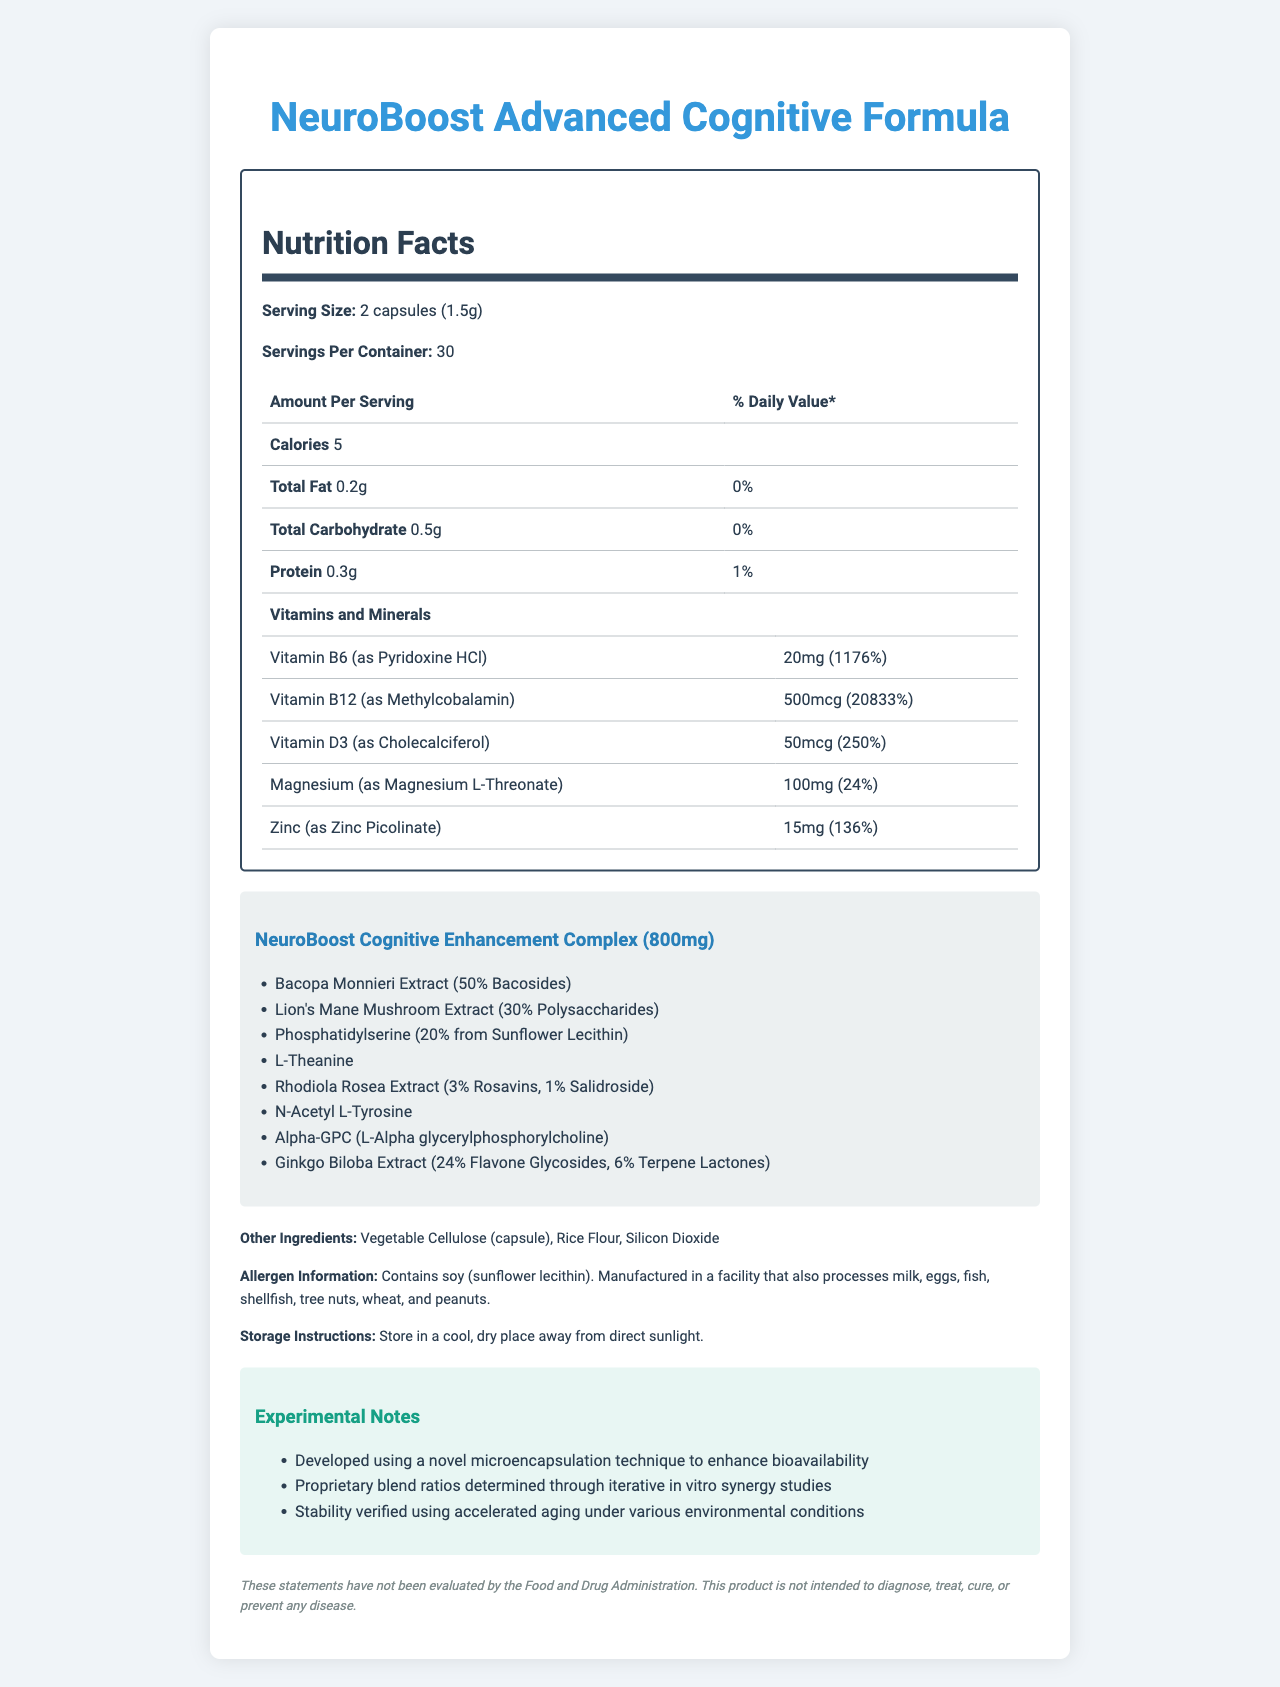what is the serving size for NeuroBoost Advanced Cognitive Formula? The serving size is listed as "2 capsules (1.5g)" in the document.
Answer: 2 capsules (1.5g) how many servings per container are there? The document states that there are 30 servings per container.
Answer: 30 how many calories are there per serving? The number of calories per serving is listed as 5.
Answer: 5 what is the proprietary blend amount per serving? The proprietary blend amount per serving is specifically mentioned as 800mg.
Answer: 800mg which vitamin has the highest daily value percentage? Vitamin B12 (as Methylcobalamin) has a daily value percentage of 20833%, which is the highest among the listed vitamins and minerals.
Answer: Vitamin B12 (as Methylcobalamin) what are the storage instructions provided for this supplement? The instructions state to store the supplement in a cool, dry place away from direct sunlight.
Answer: Store in a cool, dry place away from direct sunlight. which ingredient is listed under "other ingredients"? One of the "other ingredients" listed is Vegetable Cellulose (capsule).
Answer: Vegetable Cellulose (capsule) how much Magnesium is in one serving, and what is its daily value percentage? The document states that there is 100mg of Magnesium per serving, which amounts to 24% of the daily value.
Answer: 100mg, 24% how many grams of total fat are in one serving? The total fat per serving is listed as 0.2g.
Answer: 0.2g what technique was used to enhance bioavailability? The experimental notes mention that a novel microencapsulation technique was used to enhance bioavailability.
Answer: Novel microencapsulation technique which of the following mushrooms is included in the proprietary blend? A. Shiitake B. Reishi C. Lion's Mane The proprietary blend includes "Lion's Mane Mushroom Extract (30% Polysaccharides)".
Answer: C. Lion's Mane what is the daily value percentage of Vitamin D3 per serving? A. 100% B. 250% C. 1176% D. 24% Vitamin D3 has a daily value percentage of 250%.
Answer: B. 250% does NeuroBoost Advanced Cognitive Formula contain any soy ingredients? Yes/No The allergen information section indicates that it contains soy (sunflower lecithin).
Answer: Yes summarize the main purpose and composition of NeuroBoost Advanced Cognitive Formula. The document describes a dietary supplement called NeuroBoost Advanced Cognitive Formula that aims to enhance cognitive performance. It includes a variety of vitamins and minerals with high daily value percentages, such as Vitamin B12 and Zinc. Additionally, it features a proprietary blend of cognitive-enhancing ingredients. The supplement is noted for its use of novel techniques to improve absorption and stability under different conditions.
Answer: NeuroBoost Advanced Cognitive Formula is designed for cognitive enhancement. It contains vitamins, minerals, and a proprietary blend of ingredients such as Bacopa Monnieri, Lion's Mane Mushroom Extract, and others. It focuses on improving cognitive function through a combination of essential nutrients and unique compounds. The supplement also utilizes advanced techniques for increased bioavailability. what is the percentage of the daily value for protein in one serving? The document specifies that the daily value percentage for protein is 1% per serving.
Answer: 1% how was the stability of the product verified? The experimental notes mention that the stability was verified using accelerated aging under different environmental conditions.
Answer: Using accelerated aging under various environmental conditions is there any information provided about where the product was manufactured? The document does not provide specific information about the manufacturing location of the product.
Answer: Not enough information 